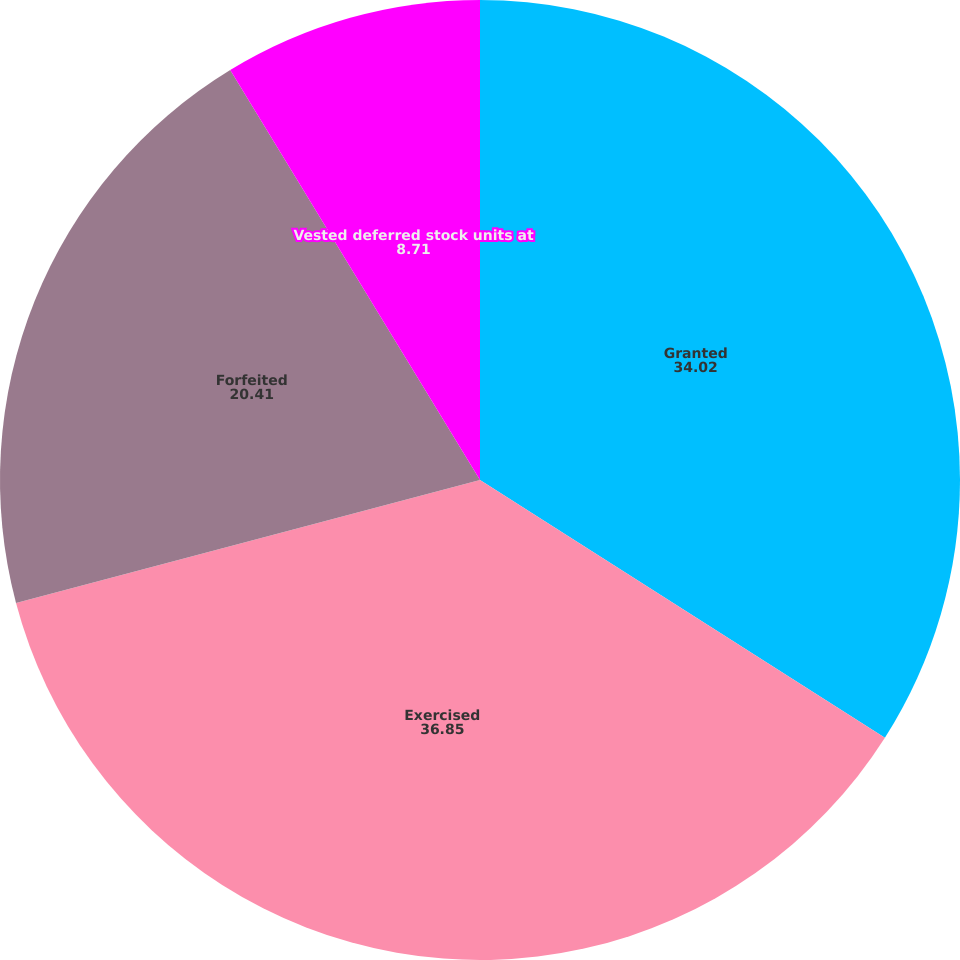Convert chart. <chart><loc_0><loc_0><loc_500><loc_500><pie_chart><fcel>Granted<fcel>Exercised<fcel>Forfeited<fcel>Vested deferred stock units at<nl><fcel>34.02%<fcel>36.85%<fcel>20.41%<fcel>8.71%<nl></chart> 